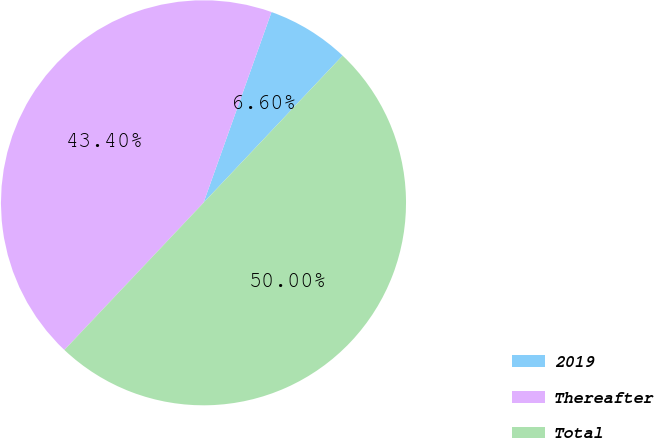<chart> <loc_0><loc_0><loc_500><loc_500><pie_chart><fcel>2019<fcel>Thereafter<fcel>Total<nl><fcel>6.6%<fcel>43.4%<fcel>50.0%<nl></chart> 